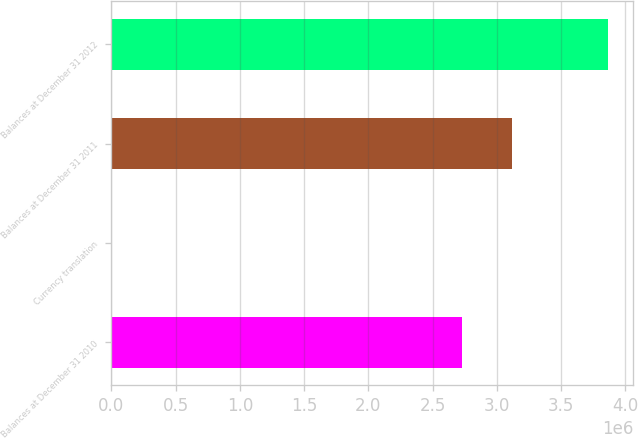<chart> <loc_0><loc_0><loc_500><loc_500><bar_chart><fcel>Balances at December 31 2010<fcel>Currency translation<fcel>Balances at December 31 2011<fcel>Balances at December 31 2012<nl><fcel>2.72778e+06<fcel>5124<fcel>3.11415e+06<fcel>3.86886e+06<nl></chart> 